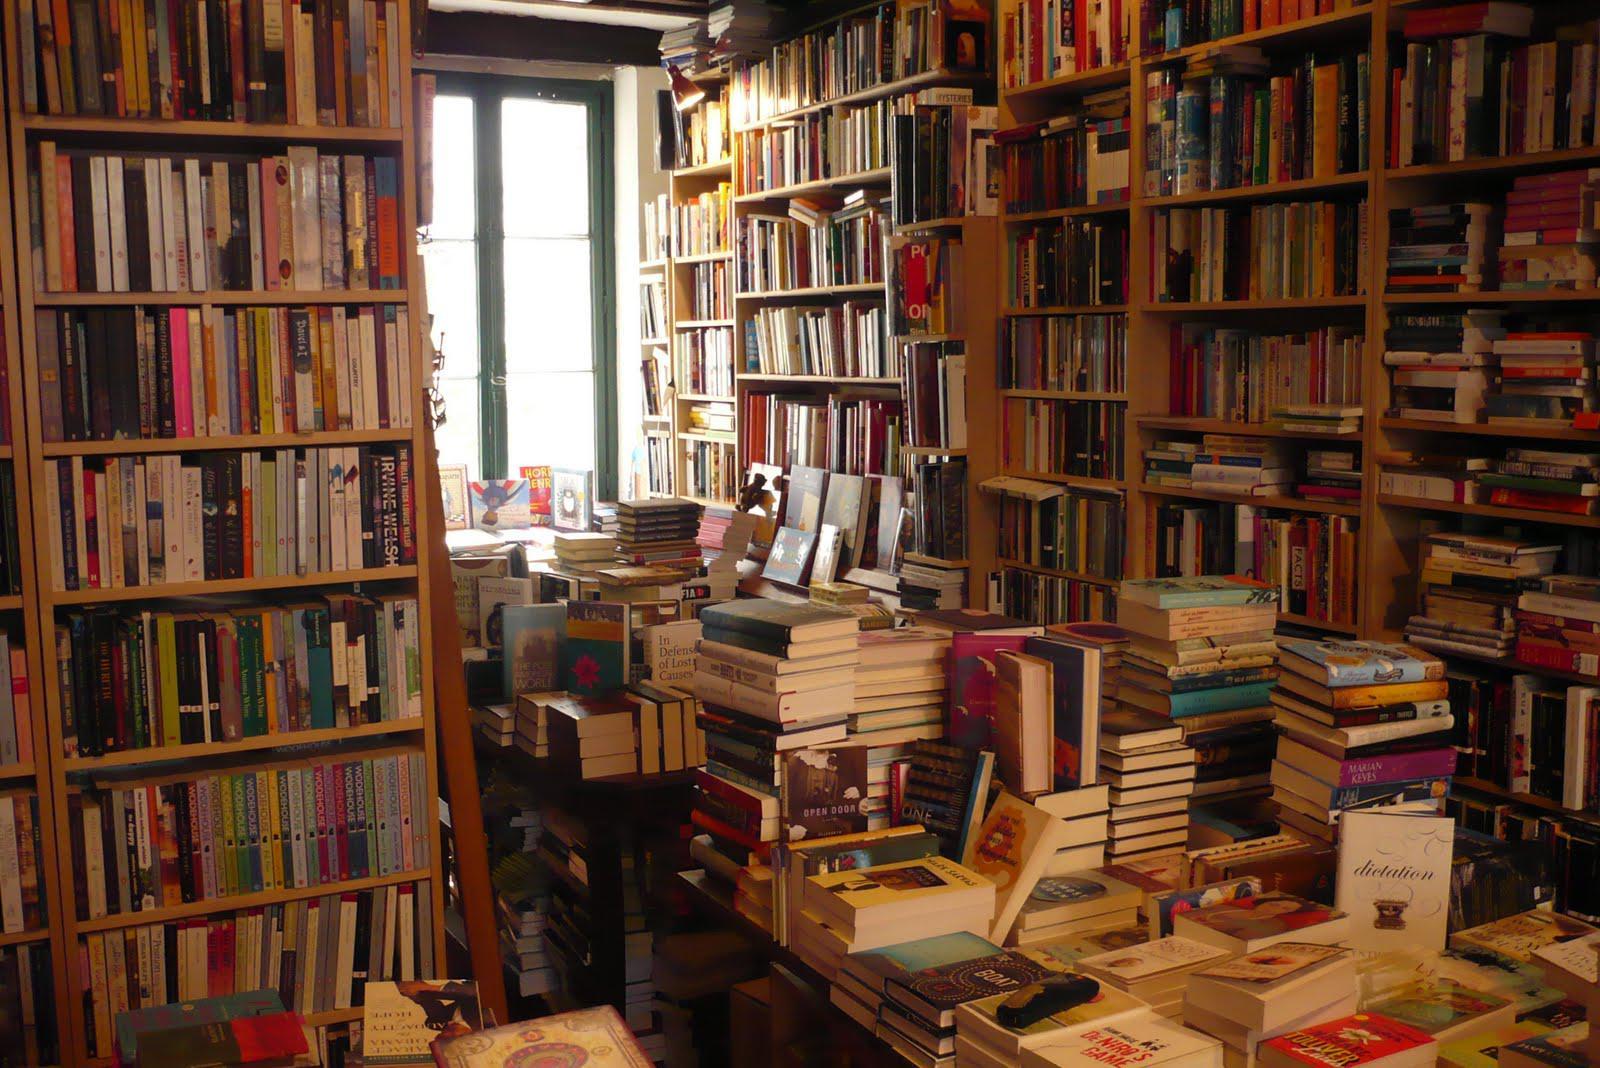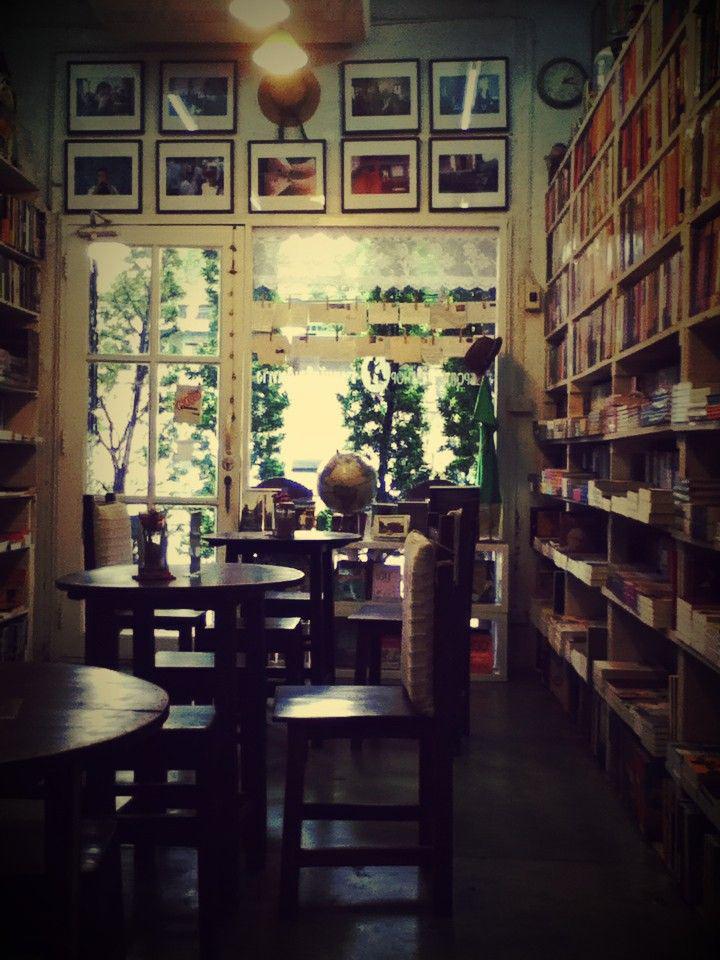The first image is the image on the left, the second image is the image on the right. Assess this claim about the two images: "A booklined reading area includes a tufted wingback chair.". Correct or not? Answer yes or no. No. The first image is the image on the left, the second image is the image on the right. Assess this claim about the two images: "At least one blue chair gives a seating area in the bookstore.". Correct or not? Answer yes or no. No. 